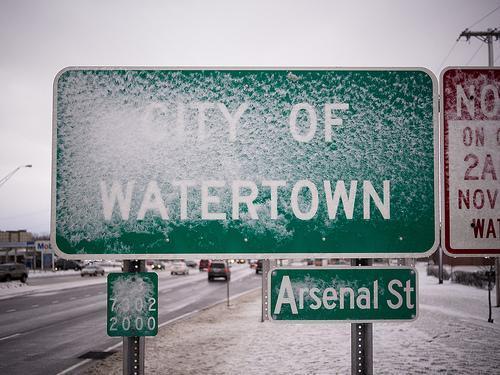How many street signs have the color red on them?
Give a very brief answer. 1. How many signs contains only one line of text?
Give a very brief answer. 1. 